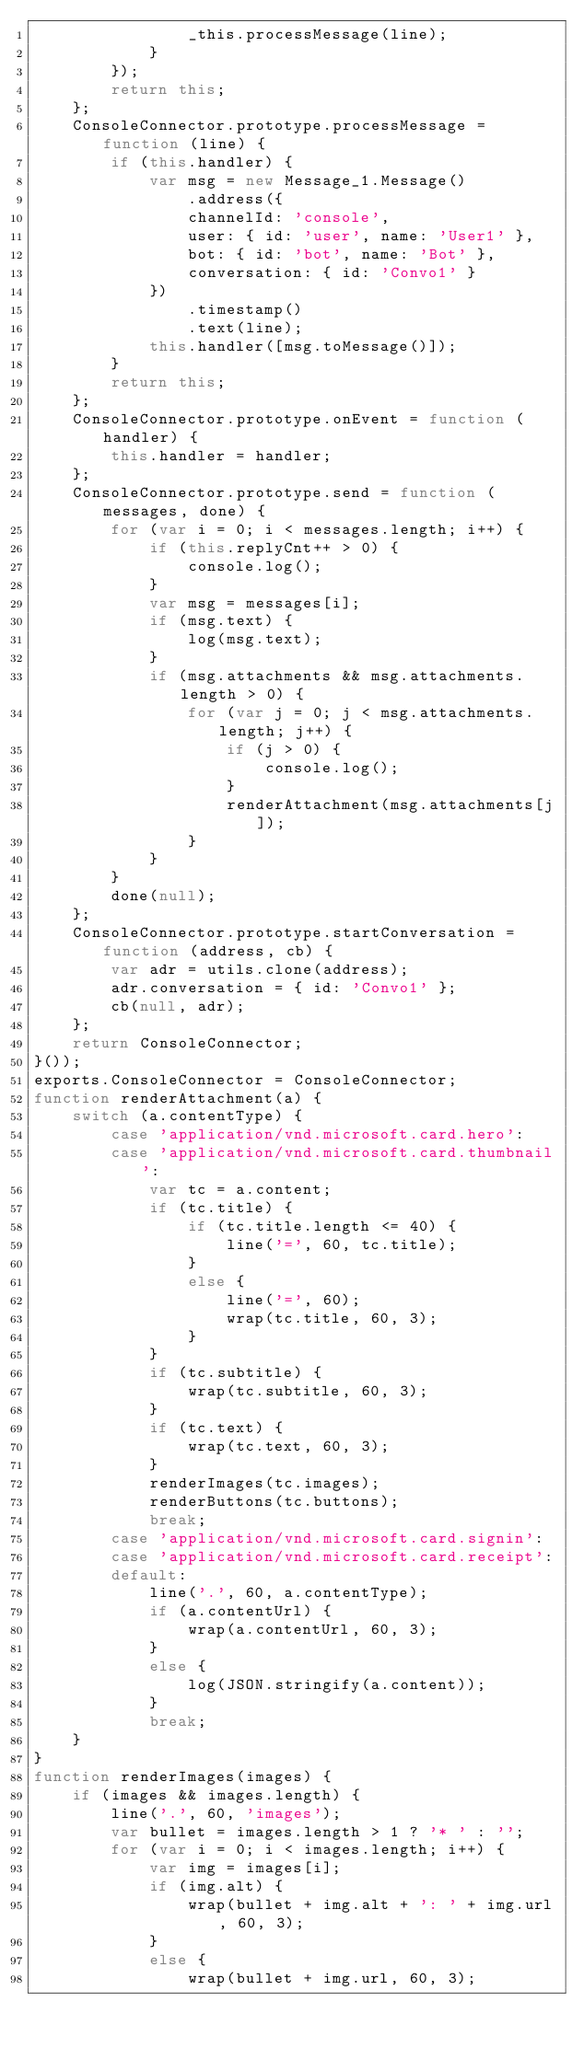Convert code to text. <code><loc_0><loc_0><loc_500><loc_500><_JavaScript_>                _this.processMessage(line);
            }
        });
        return this;
    };
    ConsoleConnector.prototype.processMessage = function (line) {
        if (this.handler) {
            var msg = new Message_1.Message()
                .address({
                channelId: 'console',
                user: { id: 'user', name: 'User1' },
                bot: { id: 'bot', name: 'Bot' },
                conversation: { id: 'Convo1' }
            })
                .timestamp()
                .text(line);
            this.handler([msg.toMessage()]);
        }
        return this;
    };
    ConsoleConnector.prototype.onEvent = function (handler) {
        this.handler = handler;
    };
    ConsoleConnector.prototype.send = function (messages, done) {
        for (var i = 0; i < messages.length; i++) {
            if (this.replyCnt++ > 0) {
                console.log();
            }
            var msg = messages[i];
            if (msg.text) {
                log(msg.text);
            }
            if (msg.attachments && msg.attachments.length > 0) {
                for (var j = 0; j < msg.attachments.length; j++) {
                    if (j > 0) {
                        console.log();
                    }
                    renderAttachment(msg.attachments[j]);
                }
            }
        }
        done(null);
    };
    ConsoleConnector.prototype.startConversation = function (address, cb) {
        var adr = utils.clone(address);
        adr.conversation = { id: 'Convo1' };
        cb(null, adr);
    };
    return ConsoleConnector;
}());
exports.ConsoleConnector = ConsoleConnector;
function renderAttachment(a) {
    switch (a.contentType) {
        case 'application/vnd.microsoft.card.hero':
        case 'application/vnd.microsoft.card.thumbnail':
            var tc = a.content;
            if (tc.title) {
                if (tc.title.length <= 40) {
                    line('=', 60, tc.title);
                }
                else {
                    line('=', 60);
                    wrap(tc.title, 60, 3);
                }
            }
            if (tc.subtitle) {
                wrap(tc.subtitle, 60, 3);
            }
            if (tc.text) {
                wrap(tc.text, 60, 3);
            }
            renderImages(tc.images);
            renderButtons(tc.buttons);
            break;
        case 'application/vnd.microsoft.card.signin':
        case 'application/vnd.microsoft.card.receipt':
        default:
            line('.', 60, a.contentType);
            if (a.contentUrl) {
                wrap(a.contentUrl, 60, 3);
            }
            else {
                log(JSON.stringify(a.content));
            }
            break;
    }
}
function renderImages(images) {
    if (images && images.length) {
        line('.', 60, 'images');
        var bullet = images.length > 1 ? '* ' : '';
        for (var i = 0; i < images.length; i++) {
            var img = images[i];
            if (img.alt) {
                wrap(bullet + img.alt + ': ' + img.url, 60, 3);
            }
            else {
                wrap(bullet + img.url, 60, 3);</code> 